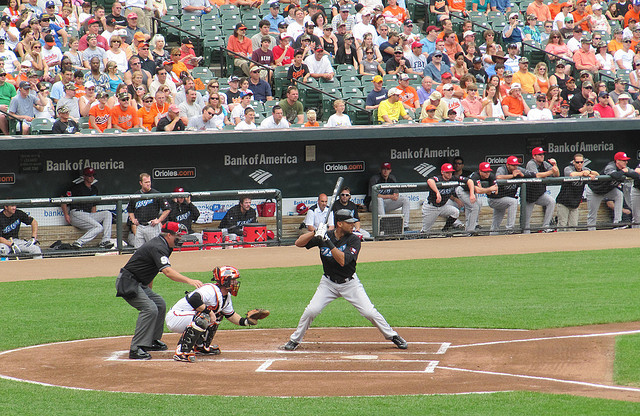Please transcribe the text information in this image. Bank of America Bank of f America Bank of America Bank of America 